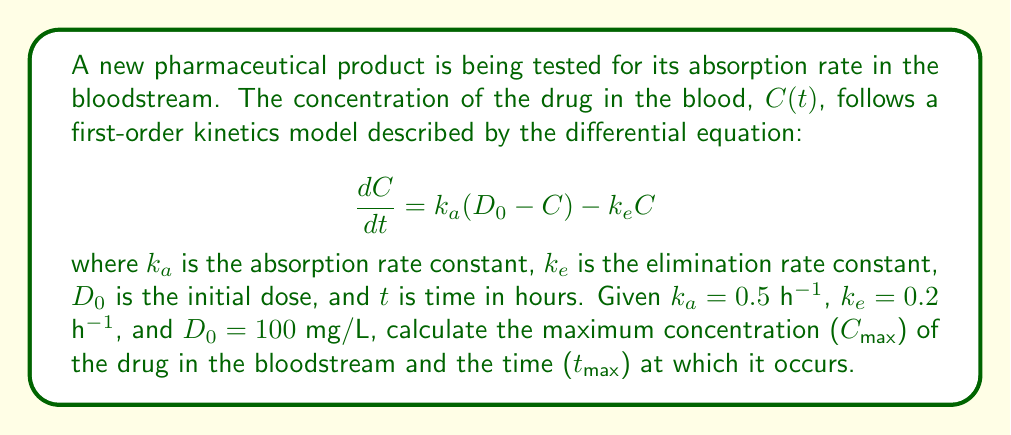Help me with this question. To solve this problem, we'll follow these steps:

1) The general solution for this first-order differential equation is:

   $$C(t) = \frac{k_aD_0}{k_a - k_e}(e^{-k_et} - e^{-k_at})$$

2) To find $C_{max}$ and $t_{max}$, we need to find the time when $\frac{dC}{dt} = 0$:

   $$\frac{dC}{dt} = \frac{k_aD_0}{k_a - k_e}(-k_ee^{-k_et} + k_ae^{-k_at}) = 0$$

3) Solving this equation:

   $$-k_ee^{-k_et} + k_ae^{-k_at} = 0$$
   $$e^{(k_a-k_e)t} = \frac{k_a}{k_e}$$

4) Taking the natural log of both sides:

   $$t_{max} = \frac{\ln(k_a/k_e)}{k_a - k_e}$$

5) Substituting the given values:

   $$t_{max} = \frac{\ln(0.5/0.2)}{0.5 - 0.2} = \frac{\ln(2.5)}{0.3} \approx 3.05\text{ hours}$$

6) To find $C_{max}$, we substitute $t_{max}$ into the general solution:

   $$C_{max} = \frac{0.5 \cdot 100}{0.5 - 0.2}(e^{-0.2 \cdot 3.05} - e^{-0.5 \cdot 3.05}) \approx 57.33\text{ mg/L}$$

Therefore, the maximum concentration is approximately 57.33 mg/L and occurs at about 3.05 hours after administration.
Answer: $C_{max} \approx 57.33$ mg/L, $t_{max} \approx 3.05$ hours 